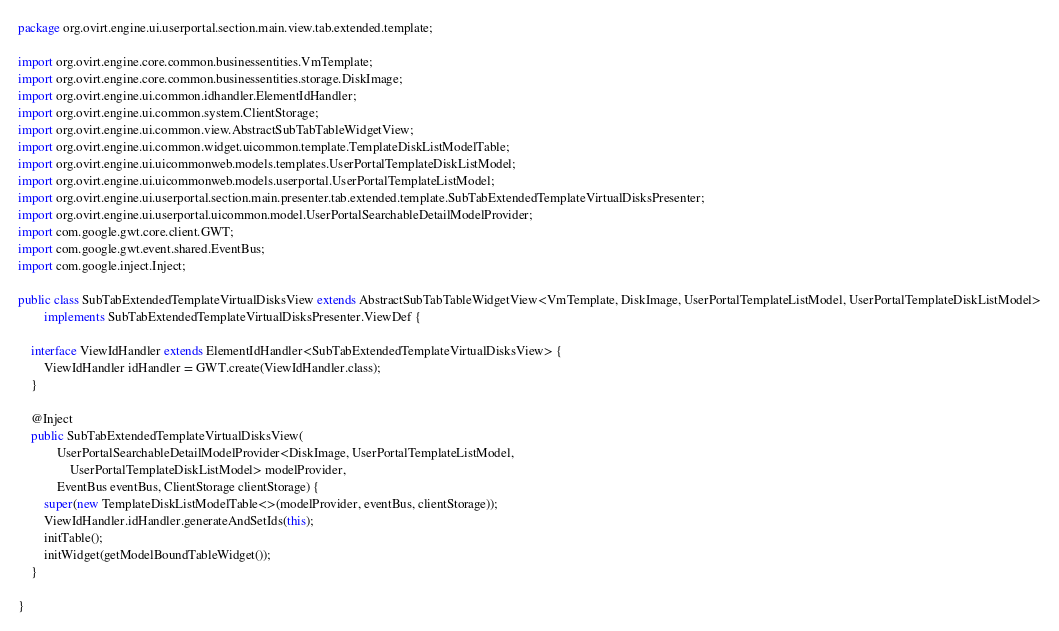<code> <loc_0><loc_0><loc_500><loc_500><_Java_>package org.ovirt.engine.ui.userportal.section.main.view.tab.extended.template;

import org.ovirt.engine.core.common.businessentities.VmTemplate;
import org.ovirt.engine.core.common.businessentities.storage.DiskImage;
import org.ovirt.engine.ui.common.idhandler.ElementIdHandler;
import org.ovirt.engine.ui.common.system.ClientStorage;
import org.ovirt.engine.ui.common.view.AbstractSubTabTableWidgetView;
import org.ovirt.engine.ui.common.widget.uicommon.template.TemplateDiskListModelTable;
import org.ovirt.engine.ui.uicommonweb.models.templates.UserPortalTemplateDiskListModel;
import org.ovirt.engine.ui.uicommonweb.models.userportal.UserPortalTemplateListModel;
import org.ovirt.engine.ui.userportal.section.main.presenter.tab.extended.template.SubTabExtendedTemplateVirtualDisksPresenter;
import org.ovirt.engine.ui.userportal.uicommon.model.UserPortalSearchableDetailModelProvider;
import com.google.gwt.core.client.GWT;
import com.google.gwt.event.shared.EventBus;
import com.google.inject.Inject;

public class SubTabExtendedTemplateVirtualDisksView extends AbstractSubTabTableWidgetView<VmTemplate, DiskImage, UserPortalTemplateListModel, UserPortalTemplateDiskListModel>
        implements SubTabExtendedTemplateVirtualDisksPresenter.ViewDef {

    interface ViewIdHandler extends ElementIdHandler<SubTabExtendedTemplateVirtualDisksView> {
        ViewIdHandler idHandler = GWT.create(ViewIdHandler.class);
    }

    @Inject
    public SubTabExtendedTemplateVirtualDisksView(
            UserPortalSearchableDetailModelProvider<DiskImage, UserPortalTemplateListModel,
                UserPortalTemplateDiskListModel> modelProvider,
            EventBus eventBus, ClientStorage clientStorage) {
        super(new TemplateDiskListModelTable<>(modelProvider, eventBus, clientStorage));
        ViewIdHandler.idHandler.generateAndSetIds(this);
        initTable();
        initWidget(getModelBoundTableWidget());
    }

}
</code> 